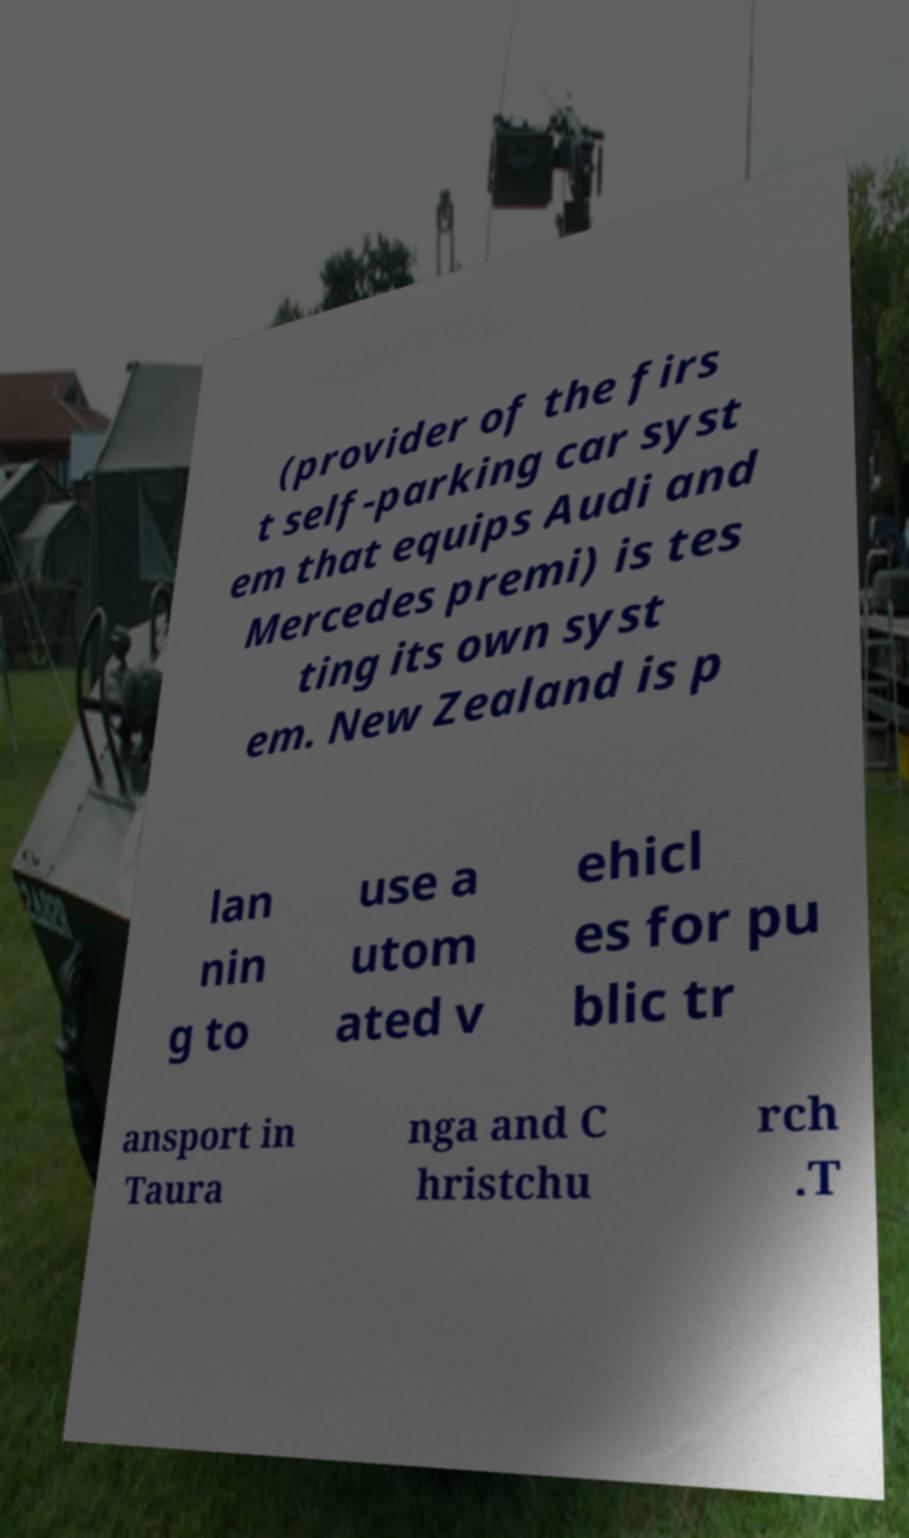Please read and relay the text visible in this image. What does it say? (provider of the firs t self-parking car syst em that equips Audi and Mercedes premi) is tes ting its own syst em. New Zealand is p lan nin g to use a utom ated v ehicl es for pu blic tr ansport in Taura nga and C hristchu rch .T 